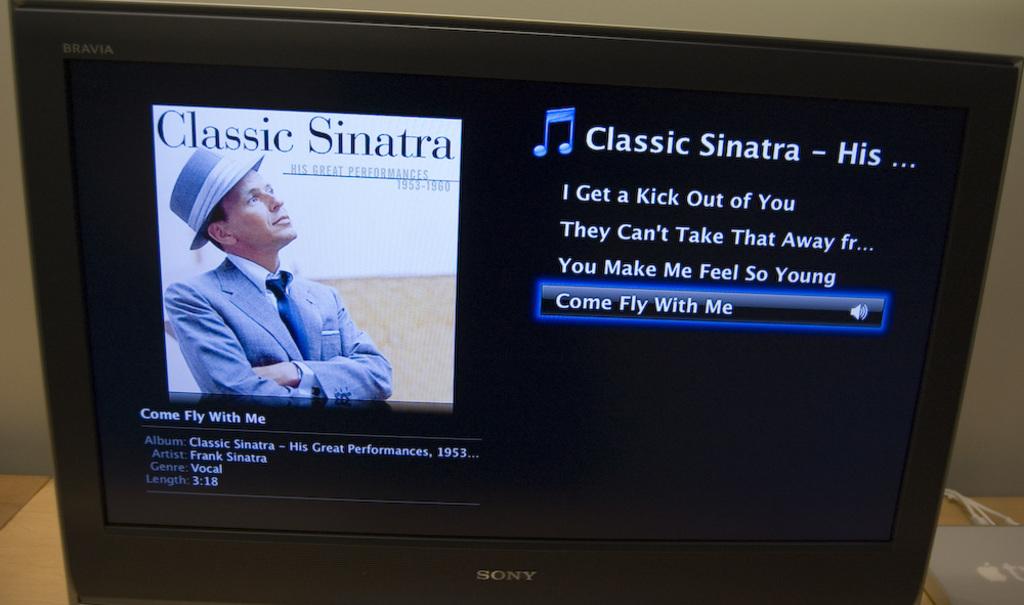What singer is pictured here?
Offer a very short reply. Sinatra. What song is highlighted?
Ensure brevity in your answer.  Come fly with me. 